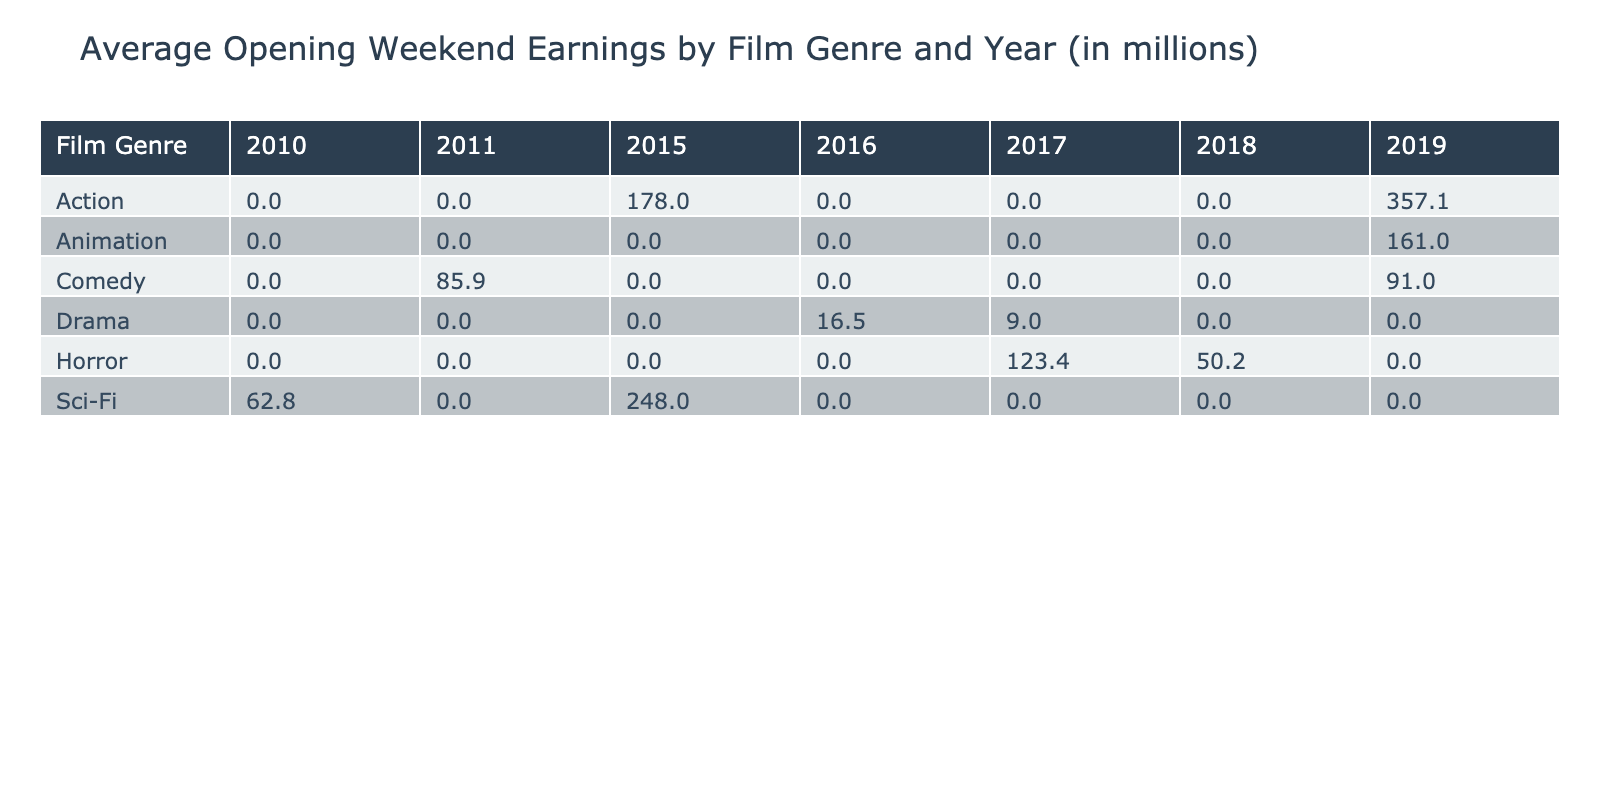What is the average opening weekend earnings for the Action genre in 2019? Looking at the table, the Action genre has one film listed for 2019, which is "Avengers: Endgame" with earnings of 357.1 million. Since it is the only entry, the average is simply this value.
Answer: 357.1 In which year did the Comedy genre earn more than 90 million on opening weekend? The table shows "It Chapter Two" with earnings of 91.0 million in 2019 and "The Hangover Part II" with 85.9 million in 2011. Therefore, the only year where the Comedy genre earned more than 90 million is 2019.
Answer: 2019 What is the total opening weekend earnings for the Sci-Fi genre across all years? The Sci-Fi genre has two films: "Star Wars: The Force Awakens" earning 248.0 million in 2015 and "Inception" earning 62.8 million in 2010. Adding these values gives 248.0 + 62.8 = 310.8 million.
Answer: 310.8 million Did Drama films ever earn more than 20 million on opening weekend? The table shows "La La Land" earning 16.5 million and "The Shape of Water" earning 9.0 million. Both values are below 20 million, indicating that no Drama film exceeded this amount on opening weekend.
Answer: No Which genre had the highest opening weekend earnings in 2015? In 2015, "Jurassic World" from the Action genre earned 208.8 million and "Star Wars: The Force Awakens" from Sci-Fi earned 248.0 million. Comparing these, Sci-Fi has the higher earnings of 248.0 million, making it the highest for that year.
Answer: Sci-Fi What is the average opening weekend earnings for Animation films between 2019? There are two Animation films listed for 2019: "The Lion King" with 191.8 million and "Frozen II" with 130.2 million. The average is calculated as (191.8 + 130.2) / 2 = 161.0 million.
Answer: 161.0 How many film genres had opening weekend earnings equal to or greater than 100 million? From the table, the genres with earnings of 100 million or more are Action (Avengers: Endgame, Furious 7, Jurassic World), Animation (The Lion King, Frozen II), Comedy (It Chapter Two), and Horror (It). Counting these, there are four genres: Action, Animation, Comedy, and Horror.
Answer: 4 Which film had the lowest opening weekend earnings, and what was the amount? The table shows "The Shape of Water" with earnings of 9.0 million being the lowest compared to other films, so this is the film in question.
Answer: The Shape of Water, 9.0 million What were the earnings of Horror films released in 2018? The Horror genre has "A Quiet Place" listed under 2018 with earnings of 50.2 million. Therefore, this is the specific film to reference for 2018 in the Horror genre.
Answer: 50.2 million 